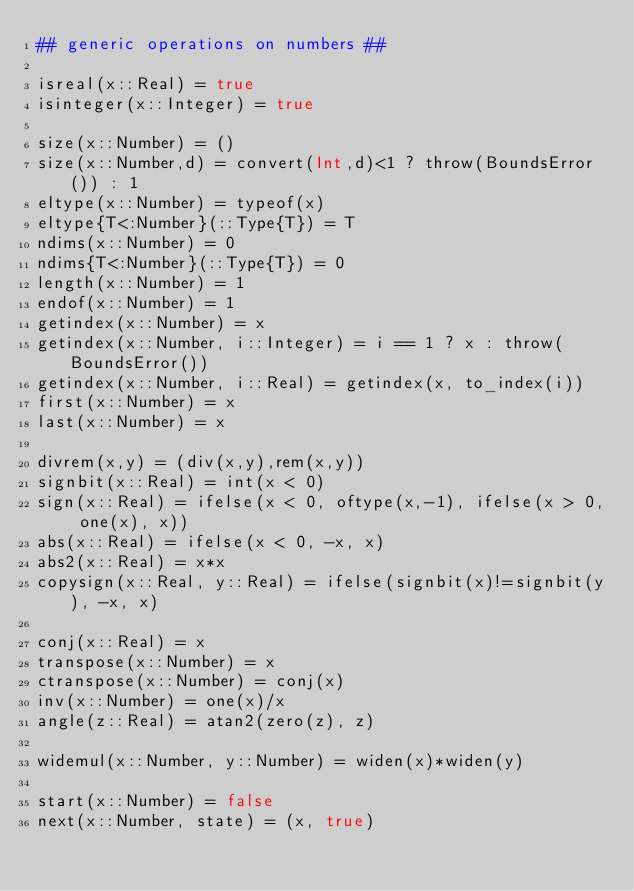<code> <loc_0><loc_0><loc_500><loc_500><_Julia_>## generic operations on numbers ##

isreal(x::Real) = true
isinteger(x::Integer) = true

size(x::Number) = ()
size(x::Number,d) = convert(Int,d)<1 ? throw(BoundsError()) : 1
eltype(x::Number) = typeof(x)
eltype{T<:Number}(::Type{T}) = T
ndims(x::Number) = 0
ndims{T<:Number}(::Type{T}) = 0
length(x::Number) = 1
endof(x::Number) = 1
getindex(x::Number) = x
getindex(x::Number, i::Integer) = i == 1 ? x : throw(BoundsError())
getindex(x::Number, i::Real) = getindex(x, to_index(i))
first(x::Number) = x
last(x::Number) = x

divrem(x,y) = (div(x,y),rem(x,y))
signbit(x::Real) = int(x < 0)
sign(x::Real) = ifelse(x < 0, oftype(x,-1), ifelse(x > 0, one(x), x))
abs(x::Real) = ifelse(x < 0, -x, x)
abs2(x::Real) = x*x
copysign(x::Real, y::Real) = ifelse(signbit(x)!=signbit(y), -x, x)

conj(x::Real) = x
transpose(x::Number) = x
ctranspose(x::Number) = conj(x)
inv(x::Number) = one(x)/x
angle(z::Real) = atan2(zero(z), z)

widemul(x::Number, y::Number) = widen(x)*widen(y)

start(x::Number) = false
next(x::Number, state) = (x, true)</code> 